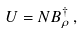Convert formula to latex. <formula><loc_0><loc_0><loc_500><loc_500>U = N B _ { \rho } ^ { \dagger } \, ,</formula> 